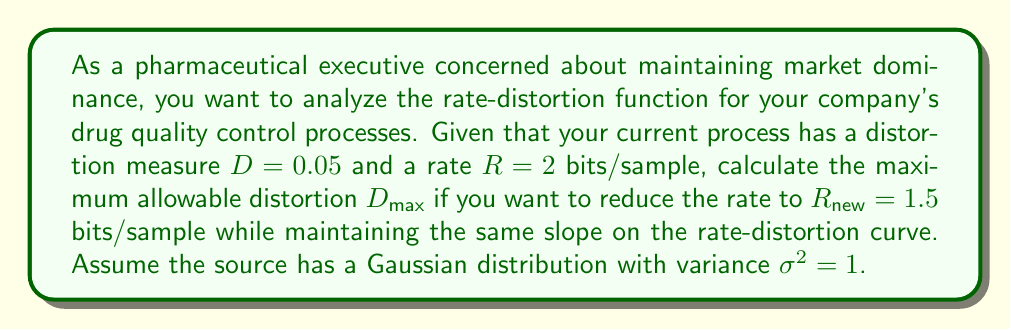Show me your answer to this math problem. To solve this problem, we need to use the rate-distortion function for a Gaussian source and the properties of its slope. Here's a step-by-step approach:

1) The rate-distortion function for a Gaussian source with variance $\sigma^2$ is given by:

   $$R(D) = \frac{1}{2} \log_2 \left(\frac{\sigma^2}{D}\right)$$

   where $D$ is the distortion and $R$ is the rate in bits/sample.

2) The slope of the rate-distortion curve at any point is given by:

   $$\frac{dR}{dD} = -\frac{1}{2D \ln 2}$$

3) We're given that initially, $D = 0.05$ and $R = 2$. Let's verify this using the rate-distortion function:

   $$2 = \frac{1}{2} \log_2 \left(\frac{1}{0.05}\right)$$

   This checks out.

4) Now, we want to find $D_{max}$ when $R_{new} = 1.5$. To do this while maintaining the same slope, we can use the slope equation:

   $$-\frac{1}{2D \ln 2} = -\frac{1}{2D_{max} \ln 2}$$

5) This simplifies to:

   $$D_{max} = D = 0.05$$

6) We can verify this using the rate-distortion function:

   $$1.5 = \frac{1}{2} \log_2 \left(\frac{1}{D_{max}}\right)$$

   $$2^3 = \frac{1}{D_{max}}$$

   $$D_{max} = \frac{1}{8} = 0.125$$

7) Therefore, the maximum allowable distortion to reduce the rate to 1.5 bits/sample while maintaining the same slope is $D_{max} = 0.125$.
Answer: $D_{max} = 0.125$ 